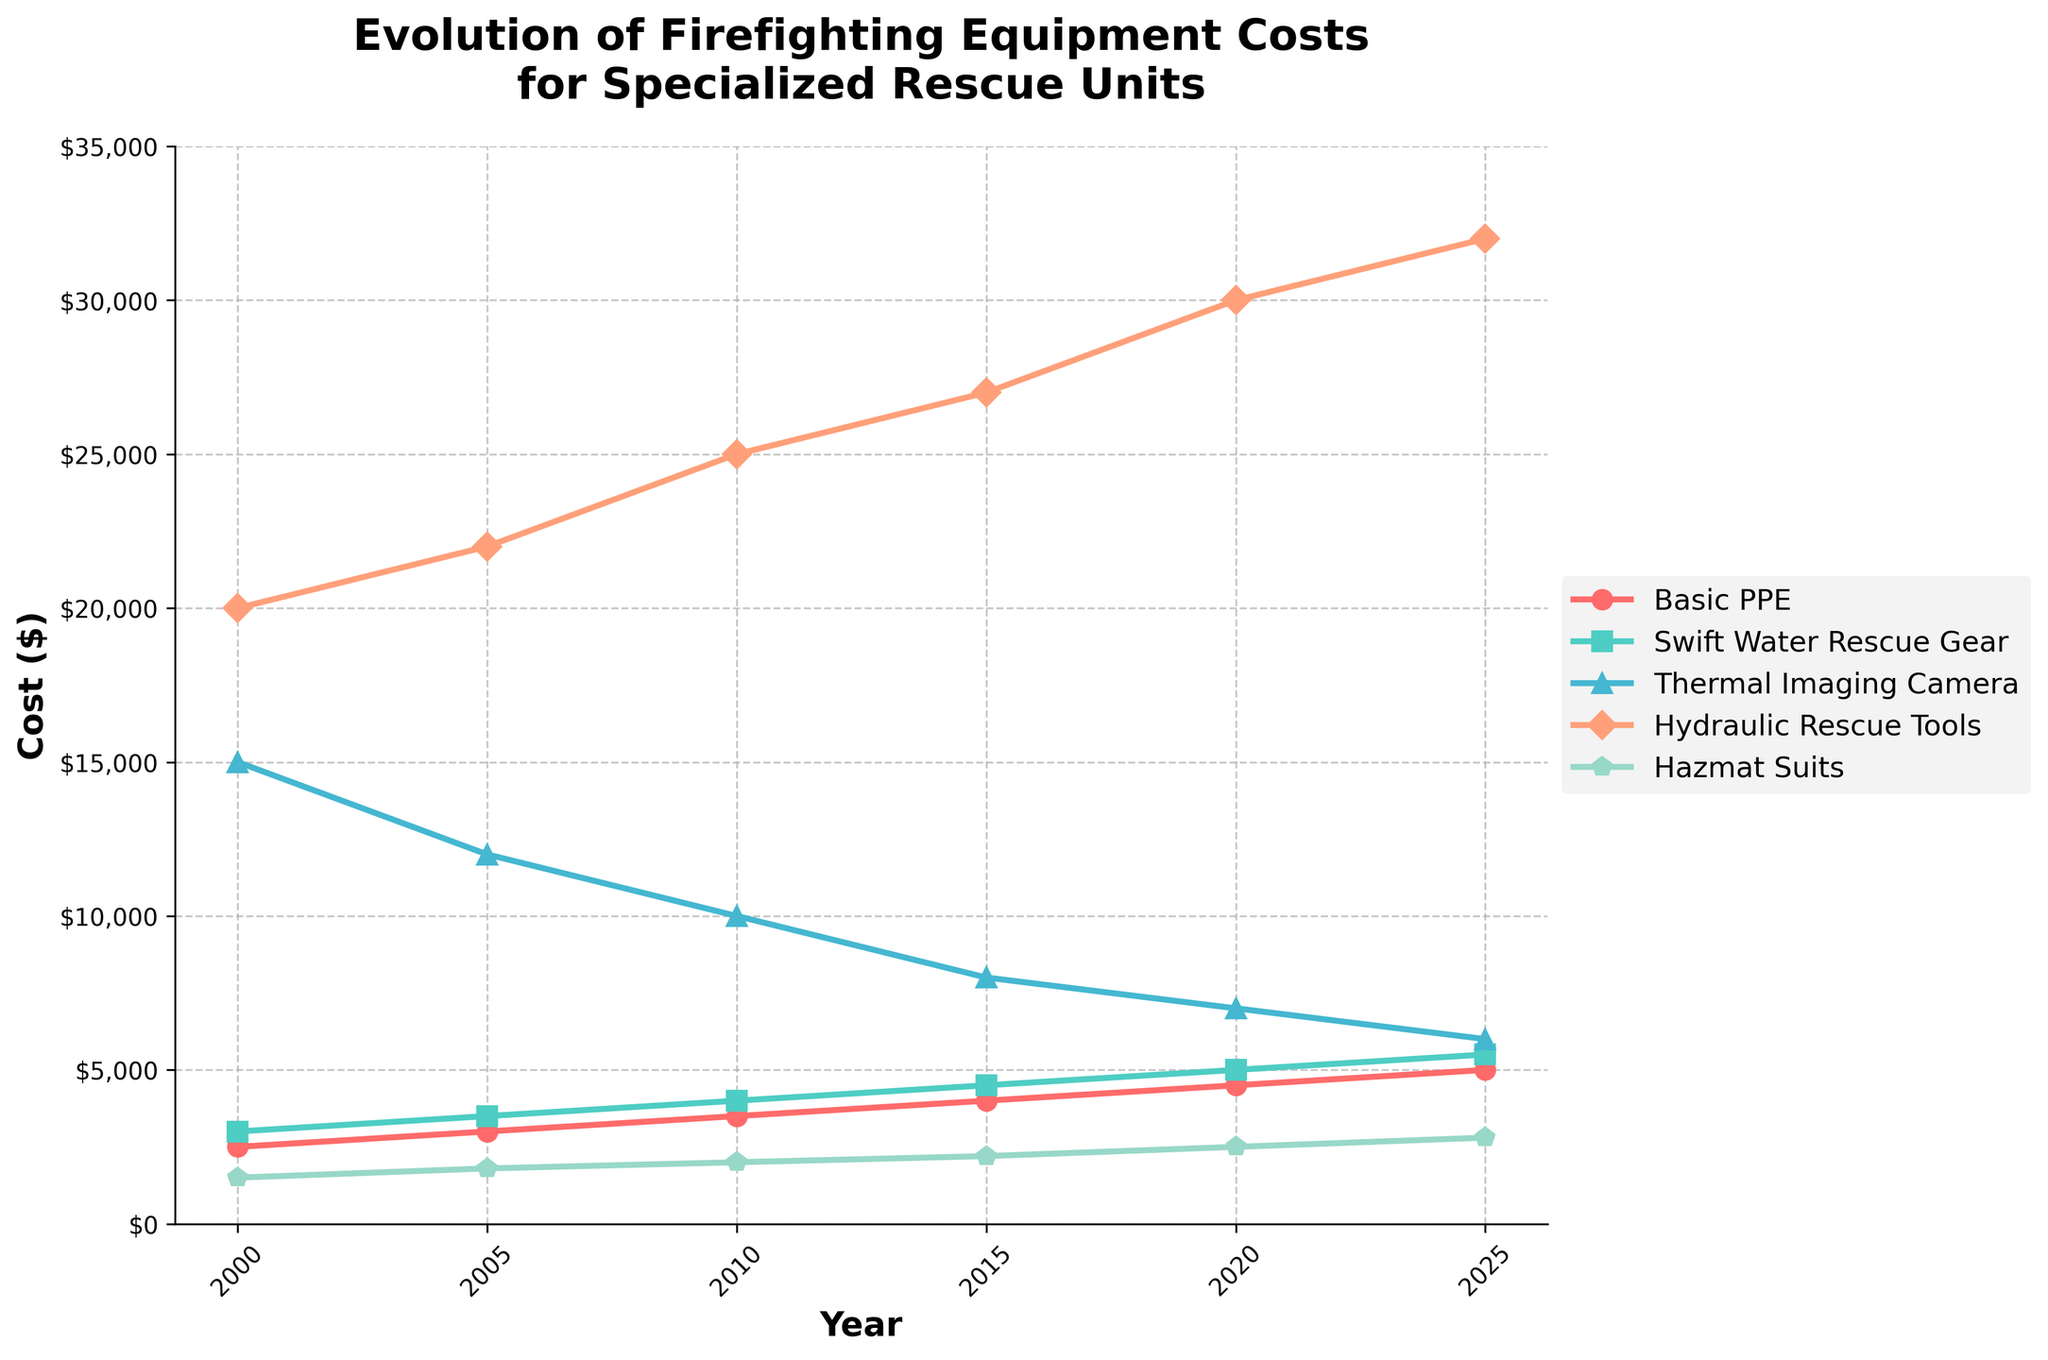What year did the Basic PPE cost $4000? We look for the year in which the Basic PPE line reaches $4000
Answer: 2015 Which equipment had the smallest cost difference from year 2000 to year 2025? Calculate the difference in costs between 2025 and 2000 for each piece of equipment. The differences are: Basic PPE ($5000 - $2500 = $2500), Swift Water Rescue Gear ($5500 - $3000 = $2500), Thermal Imaging Camera ($6000 - $15000 = -$9000), Hydraulic Rescue Tools ($32000 - $20000 = $12000), Hazmat Suits ($2800 - $1500 = $1300). The smallest difference is for the Hazmat Suits
Answer: Hazmat Suits Which piece of equipment appears to have the steepest increasing cost trend over the years? Look at the slope of the lines representing the costs of each equipment. The steeper the slope, the faster the increase. Hydraulic Rescue Tools show the steepest increase
Answer: Hydraulic Rescue Tools Between which years did the cost of the Thermal Imaging Camera drop the most? Compare the costs of the Thermal Imaging Camera between each pair of consecutive years: 2000-2005 ($15000-$12000 = $3000), 2005-2010 ($12000-$10000 = $2000), 2010-2015 ($10000-$8000 = $2000), 2015-2020 ($8000-$7000 = $1000), 2020-2025 ($7000-$6000 = $1000). The largest drop is between 2000 and 2005
Answer: 2000-2005 How did the cost of Hazmat Suits change from 2010 to 2025? Find the cost of Hazmat Suits in 2010 ($2000) and in 2025 ($2800), then calculate the change $2800-$2000=$800
Answer: Increased by $800 Which two pieces of equipment had identical costs in any given year? Compare the costs of each piece of equipment for every year. Basic PPE and Swift Water Rescue Gear both cost $2500 in 2025
Answer: Basic PPE and Swift Water Rescue Gear ($2500) in 2025 In what year did the cost of Hydraulic Rescue Tools reach $30000? Look at the Hydraulic Rescue Tools line and identify the year when it reaches $30000
Answer: 2020 